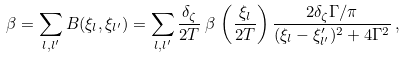<formula> <loc_0><loc_0><loc_500><loc_500>& \beta = \sum _ { l , l ^ { \prime } } B ( \xi _ { l } , \xi _ { l ^ { \prime } } ) = \sum _ { l , l ^ { \prime } } \frac { \delta _ { \zeta } } { 2 T } \, \beta \, \left ( \frac { \xi _ { l } } { 2 T } \right ) \frac { 2 \delta _ { \zeta } \Gamma / \pi } { ( \xi _ { l } - \xi _ { l ^ { \prime } } ^ { \prime } ) ^ { 2 } + 4 \Gamma ^ { 2 } } \, ,</formula> 